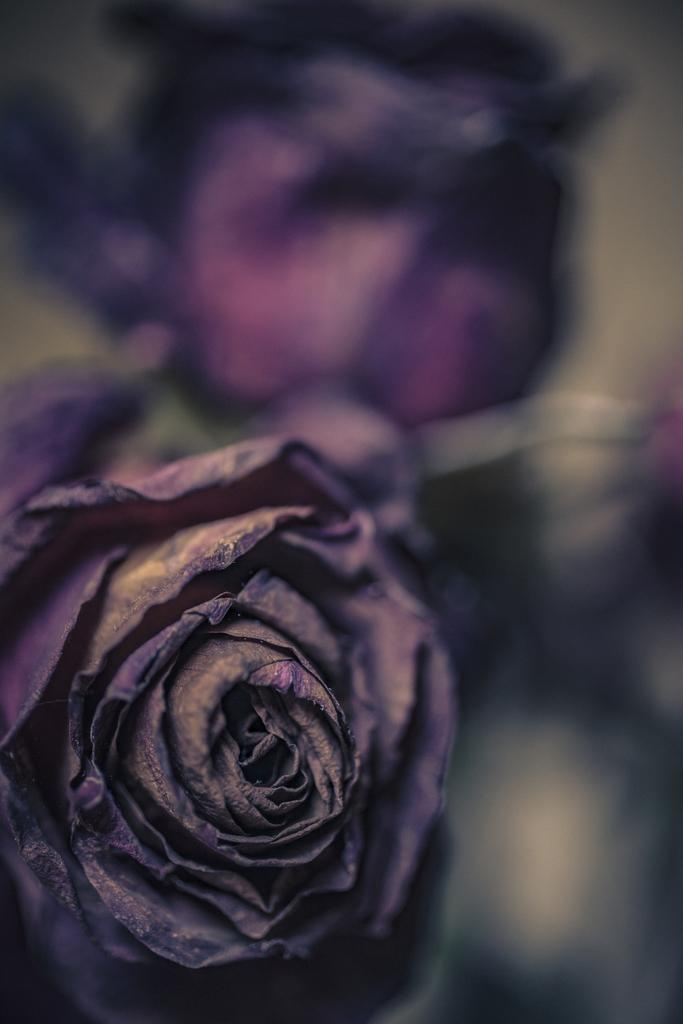What is the main subject of the image? There is a flower in the image. Can you describe the background of the image? The background of the image appears blurred. What time of day is depicted in the image? The time of day is not mentioned or depicted in the image. What type of bucket can be seen near the flower in the image? There is no bucket present in the image. What order is the flower following in the image? The flower is not following any specific order in the image. 